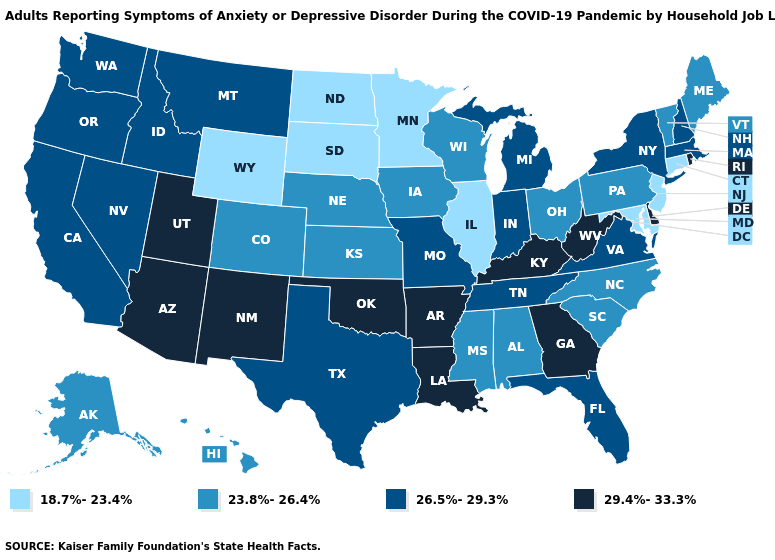Name the states that have a value in the range 23.8%-26.4%?
Be succinct. Alabama, Alaska, Colorado, Hawaii, Iowa, Kansas, Maine, Mississippi, Nebraska, North Carolina, Ohio, Pennsylvania, South Carolina, Vermont, Wisconsin. Does Hawaii have a higher value than Tennessee?
Short answer required. No. Which states have the lowest value in the Northeast?
Concise answer only. Connecticut, New Jersey. Among the states that border Michigan , which have the lowest value?
Answer briefly. Ohio, Wisconsin. Which states hav the highest value in the Northeast?
Short answer required. Rhode Island. What is the value of Oregon?
Keep it brief. 26.5%-29.3%. What is the value of Wyoming?
Write a very short answer. 18.7%-23.4%. What is the highest value in the West ?
Quick response, please. 29.4%-33.3%. What is the highest value in the USA?
Quick response, please. 29.4%-33.3%. What is the lowest value in the MidWest?
Answer briefly. 18.7%-23.4%. Does the map have missing data?
Concise answer only. No. What is the lowest value in the USA?
Write a very short answer. 18.7%-23.4%. Does the first symbol in the legend represent the smallest category?
Give a very brief answer. Yes. Does Wyoming have the lowest value in the West?
Answer briefly. Yes. 